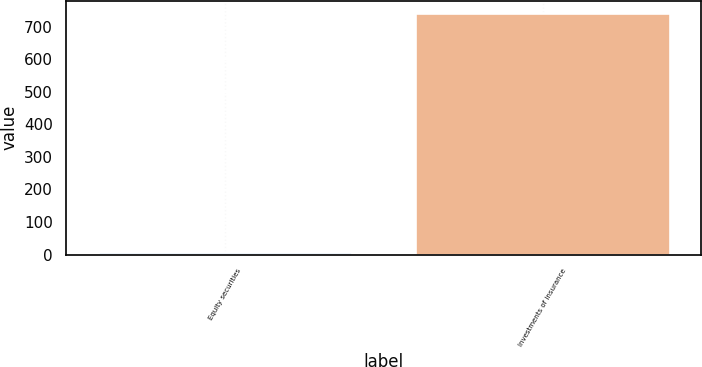Convert chart to OTSL. <chart><loc_0><loc_0><loc_500><loc_500><bar_chart><fcel>Equity securities<fcel>Investments of insurance<nl><fcel>8<fcel>742<nl></chart> 